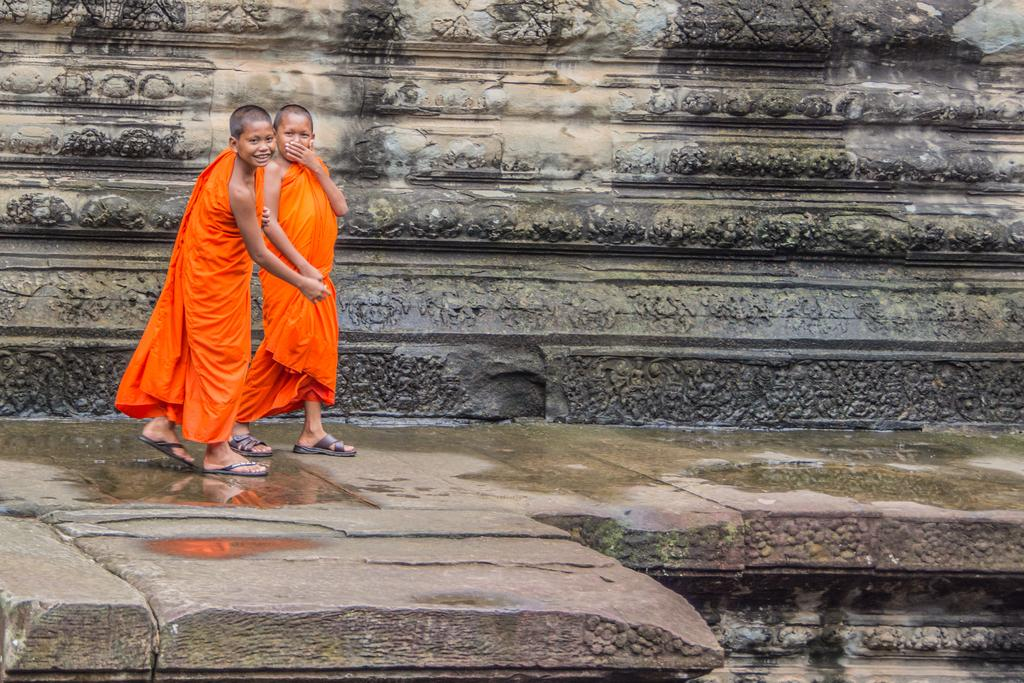How many monks are present in the image? There are two monks in the image. What are the monks doing in the image? The monks are walking. What expression do the monks have on their faces? The monks have smiles on their faces. What can be seen in the background of the image? There is a rock in the background of the image. What type of dress is the monk wearing in the image? The monks in the image are wearing traditional monk robes, not dresses. What type of plough can be seen in the image? There is no plough present in the image; it features two monks walking and smiling. 